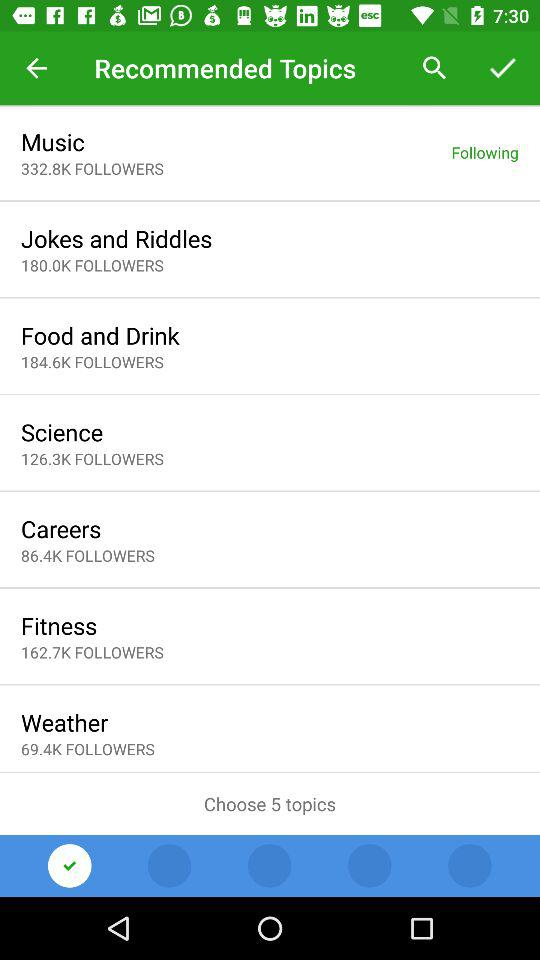What is the name of the topic that has 86.4K followers? The name of the topic that has 86.4K followers is "Careers". 